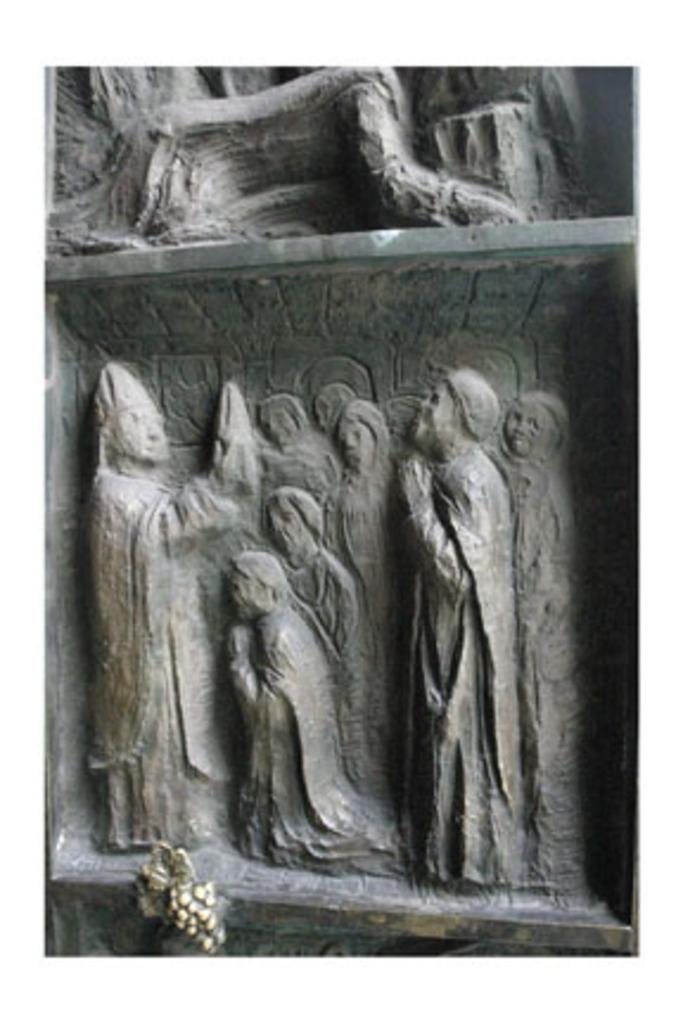What type of artwork is featured in the image? There are sculptures in the image. What do the sculptures depict? The sculptures depict a group of people. Where are the sculptures located? The sculptures are on a wall. What is the opinion of the sculptures on the topic of climate change? The sculptures cannot express opinions, as they are inanimate objects. 